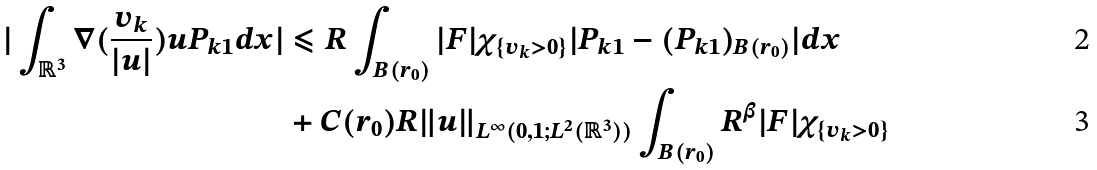<formula> <loc_0><loc_0><loc_500><loc_500>| \int _ { \mathbb { R } ^ { 3 } } \nabla ( \frac { v _ { k } } { | u | } ) u P _ { k 1 } d x | & \leqslant R \int _ { B ( r _ { 0 } ) } | F | \chi _ { \{ v _ { k } > 0 \} } | P _ { k 1 } - ( P _ { k 1 } ) _ { B ( r _ { 0 } ) } | d x \\ & + C ( r _ { 0 } ) R \| u \| _ { L ^ { \infty } ( 0 , 1 ; L ^ { 2 } ( \mathbb { R } ^ { 3 } ) ) } \int _ { B ( r _ { 0 } ) } R ^ { \beta } | F | \chi _ { \{ v _ { k } > 0 \} }</formula> 